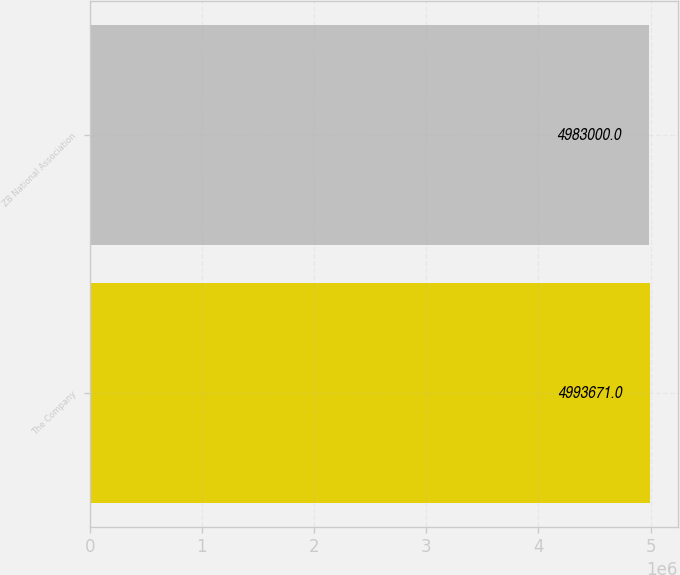Convert chart to OTSL. <chart><loc_0><loc_0><loc_500><loc_500><bar_chart><fcel>The Company<fcel>ZB National Association<nl><fcel>4.99367e+06<fcel>4.983e+06<nl></chart> 